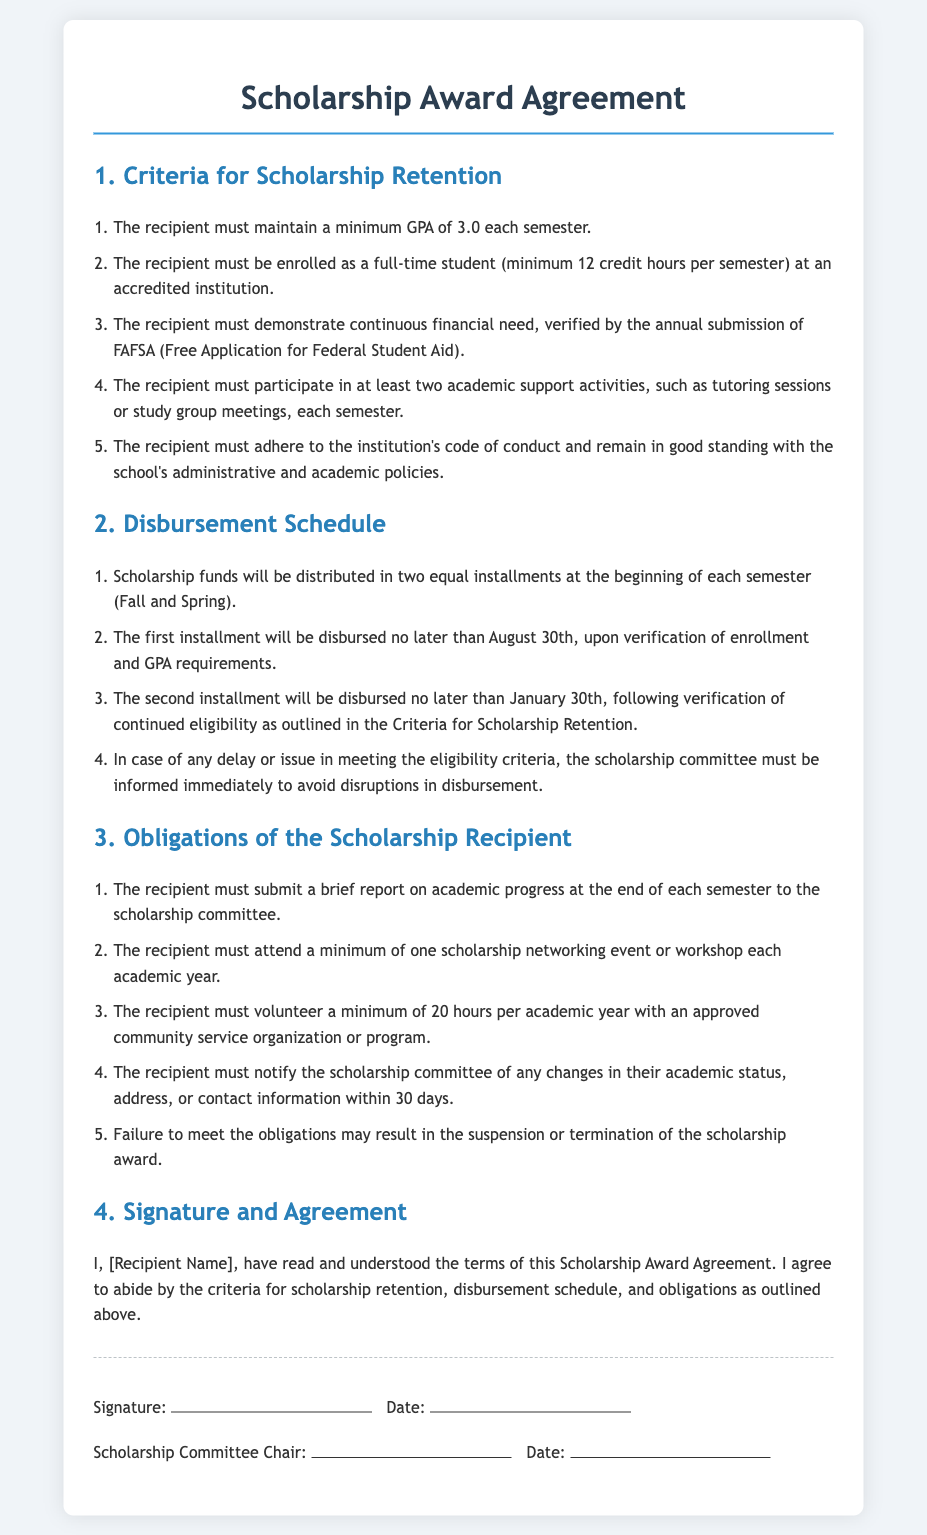What is the minimum GPA required? The document states that the recipient must maintain a minimum GPA of 3.0 each semester.
Answer: 3.0 How many credit hours must the recipient be enrolled in? The agreement specifies that the recipient must be enrolled as a full-time student with a minimum of 12 credit hours per semester.
Answer: 12 When is the first installment disbursed? The document indicates that the first installment will be disbursed no later than August 30th.
Answer: August 30th What is the minimum number of academic support activities required? The agreement states that the recipient must participate in at least two academic support activities each semester.
Answer: Two What is the minimum volunteer hours required per academic year? The document specifies that the recipient must volunteer a minimum of 20 hours per academic year.
Answer: 20 What must the recipient submit at the end of each semester? According to the agreement, the recipient must submit a brief report on academic progress to the scholarship committee.
Answer: Brief report What action should the recipient take if there is a delay in meeting eligibility criteria? The document mentions that the scholarship committee must be informed immediately to avoid disruptions in disbursement.
Answer: Inform the scholarship committee What date is the second installment disbursed by? The agreement states that the second installment will be disbursed no later than January 30th.
Answer: January 30th What consequence may result from failing to meet obligations? The document mentions that failure to meet the obligations may result in the suspension or termination of the scholarship award.
Answer: Suspension or termination 